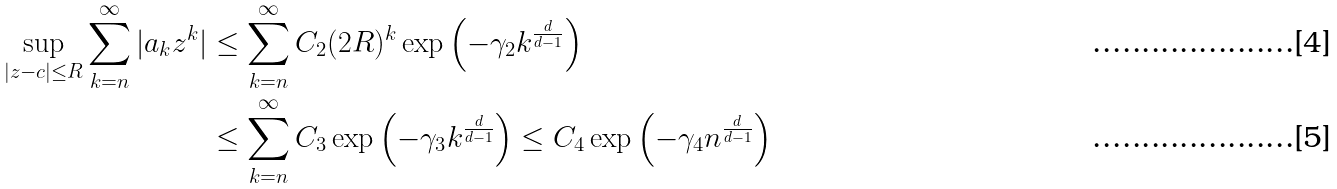Convert formula to latex. <formula><loc_0><loc_0><loc_500><loc_500>\sup _ { | z - c | \leq R } \sum _ { k = n } ^ { \infty } | a _ { k } z ^ { k } | & \leq \sum _ { k = n } ^ { \infty } C _ { 2 } ( 2 R ) ^ { k } \exp \left ( - \gamma _ { 2 } k ^ { \frac { d } { d - 1 } } \right ) \\ & \leq \sum _ { k = n } ^ { \infty } C _ { 3 } \exp \left ( - \gamma _ { 3 } k ^ { \frac { d } { d - 1 } } \right ) \leq C _ { 4 } \exp \left ( - \gamma _ { 4 } n ^ { \frac { d } { d - 1 } } \right )</formula> 